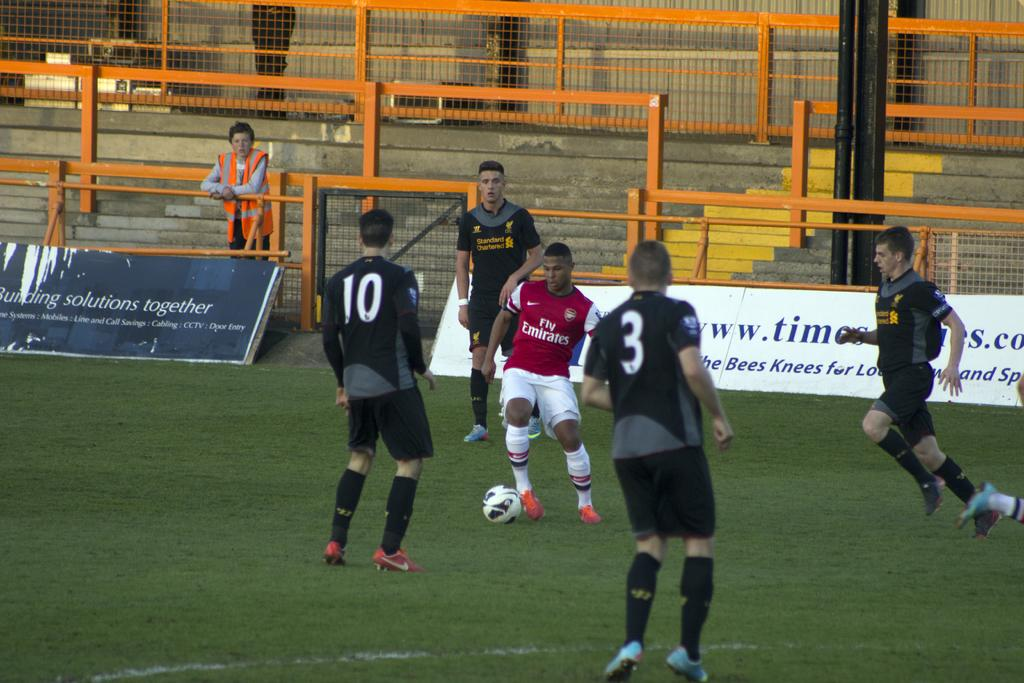<image>
Offer a succinct explanation of the picture presented. a team of soccer players, one has #10 on the jersey and other has a 3. 